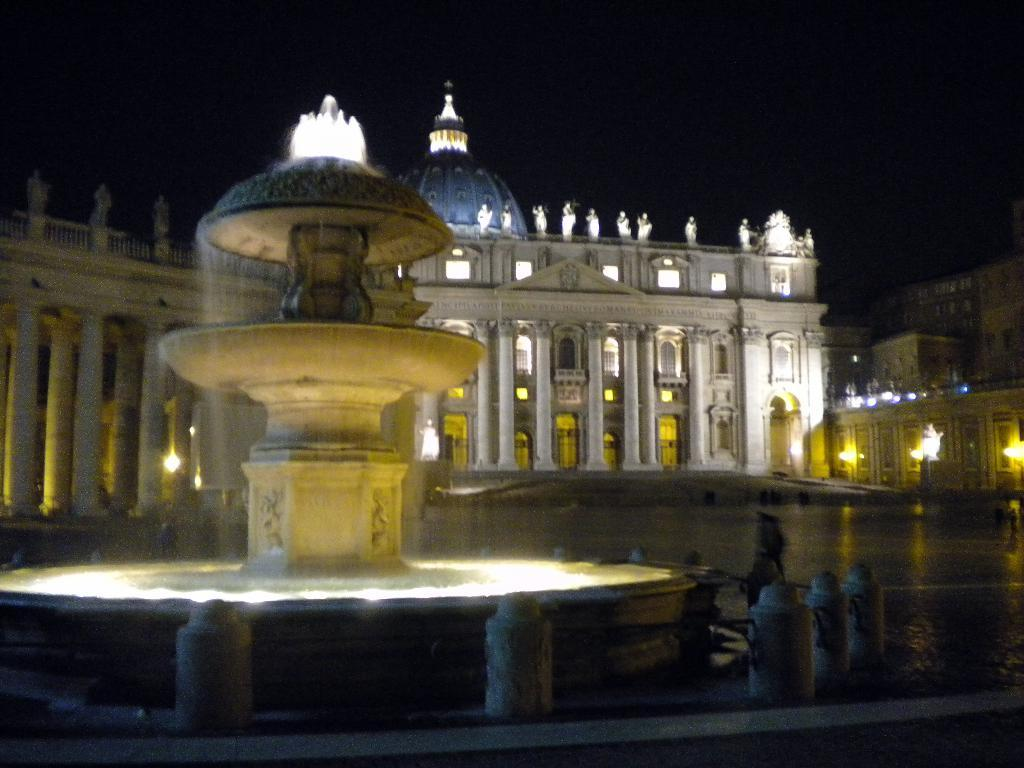What type of structures are present in the image? There are buildings with sculptures in the image. What is a notable feature in the image? There is a fountain in the image. What are the poles in the image used for? The poles in the image are likely used for supporting lights or other decorations. What can be seen in the sky in the image? The sky is visible in the image. What is visible at ground level in the image? The ground is visible in the image. What type of animal can be seen interacting with the fountain in the image? There are no animals present in the image; it only features buildings, sculptures, a fountain, poles, lights, and the sky and ground. 